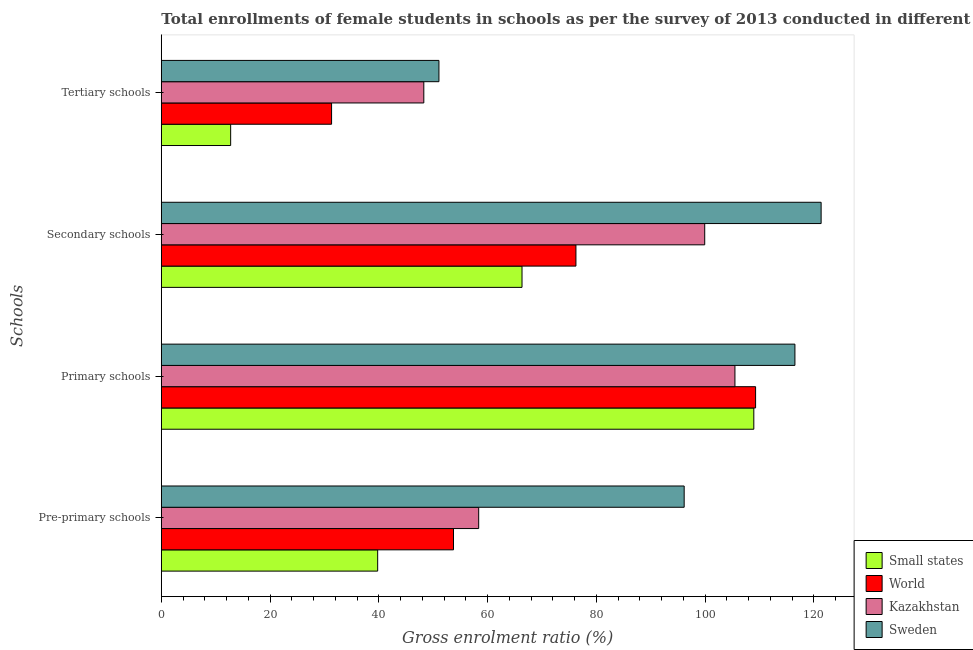Are the number of bars on each tick of the Y-axis equal?
Ensure brevity in your answer.  Yes. How many bars are there on the 3rd tick from the top?
Your answer should be compact. 4. How many bars are there on the 3rd tick from the bottom?
Make the answer very short. 4. What is the label of the 4th group of bars from the top?
Provide a succinct answer. Pre-primary schools. What is the gross enrolment ratio(female) in pre-primary schools in Kazakhstan?
Keep it short and to the point. 58.37. Across all countries, what is the maximum gross enrolment ratio(female) in secondary schools?
Give a very brief answer. 121.36. Across all countries, what is the minimum gross enrolment ratio(female) in primary schools?
Your response must be concise. 105.51. In which country was the gross enrolment ratio(female) in secondary schools minimum?
Provide a short and direct response. Small states. What is the total gross enrolment ratio(female) in primary schools in the graph?
Ensure brevity in your answer.  440.32. What is the difference between the gross enrolment ratio(female) in tertiary schools in Small states and that in Sweden?
Offer a terse response. -38.31. What is the difference between the gross enrolment ratio(female) in primary schools in Kazakhstan and the gross enrolment ratio(female) in secondary schools in Sweden?
Give a very brief answer. -15.85. What is the average gross enrolment ratio(female) in pre-primary schools per country?
Offer a very short reply. 62.02. What is the difference between the gross enrolment ratio(female) in secondary schools and gross enrolment ratio(female) in pre-primary schools in World?
Offer a very short reply. 22.52. In how many countries, is the gross enrolment ratio(female) in primary schools greater than 112 %?
Keep it short and to the point. 1. What is the ratio of the gross enrolment ratio(female) in primary schools in World to that in Sweden?
Your response must be concise. 0.94. Is the gross enrolment ratio(female) in primary schools in Sweden less than that in Kazakhstan?
Offer a terse response. No. What is the difference between the highest and the second highest gross enrolment ratio(female) in pre-primary schools?
Ensure brevity in your answer.  37.79. What is the difference between the highest and the lowest gross enrolment ratio(female) in secondary schools?
Provide a short and direct response. 55.01. In how many countries, is the gross enrolment ratio(female) in pre-primary schools greater than the average gross enrolment ratio(female) in pre-primary schools taken over all countries?
Offer a very short reply. 1. Is it the case that in every country, the sum of the gross enrolment ratio(female) in secondary schools and gross enrolment ratio(female) in pre-primary schools is greater than the sum of gross enrolment ratio(female) in primary schools and gross enrolment ratio(female) in tertiary schools?
Your answer should be very brief. No. What does the 3rd bar from the bottom in Tertiary schools represents?
Make the answer very short. Kazakhstan. How many bars are there?
Ensure brevity in your answer.  16. Are all the bars in the graph horizontal?
Make the answer very short. Yes. Does the graph contain any zero values?
Give a very brief answer. No. How many legend labels are there?
Provide a short and direct response. 4. How are the legend labels stacked?
Keep it short and to the point. Vertical. What is the title of the graph?
Your response must be concise. Total enrollments of female students in schools as per the survey of 2013 conducted in different countries. Does "Japan" appear as one of the legend labels in the graph?
Your answer should be compact. No. What is the label or title of the X-axis?
Keep it short and to the point. Gross enrolment ratio (%). What is the label or title of the Y-axis?
Your answer should be compact. Schools. What is the Gross enrolment ratio (%) in Small states in Pre-primary schools?
Provide a succinct answer. 39.79. What is the Gross enrolment ratio (%) in World in Pre-primary schools?
Make the answer very short. 53.74. What is the Gross enrolment ratio (%) in Kazakhstan in Pre-primary schools?
Your answer should be compact. 58.37. What is the Gross enrolment ratio (%) in Sweden in Pre-primary schools?
Offer a very short reply. 96.17. What is the Gross enrolment ratio (%) in Small states in Primary schools?
Your response must be concise. 108.98. What is the Gross enrolment ratio (%) of World in Primary schools?
Your answer should be very brief. 109.3. What is the Gross enrolment ratio (%) in Kazakhstan in Primary schools?
Provide a succinct answer. 105.51. What is the Gross enrolment ratio (%) of Sweden in Primary schools?
Give a very brief answer. 116.54. What is the Gross enrolment ratio (%) in Small states in Secondary schools?
Offer a very short reply. 66.34. What is the Gross enrolment ratio (%) in World in Secondary schools?
Your answer should be compact. 76.26. What is the Gross enrolment ratio (%) of Kazakhstan in Secondary schools?
Provide a succinct answer. 99.95. What is the Gross enrolment ratio (%) in Sweden in Secondary schools?
Offer a very short reply. 121.36. What is the Gross enrolment ratio (%) in Small states in Tertiary schools?
Offer a terse response. 12.75. What is the Gross enrolment ratio (%) of World in Tertiary schools?
Keep it short and to the point. 31.32. What is the Gross enrolment ratio (%) in Kazakhstan in Tertiary schools?
Ensure brevity in your answer.  48.28. What is the Gross enrolment ratio (%) in Sweden in Tertiary schools?
Ensure brevity in your answer.  51.06. Across all Schools, what is the maximum Gross enrolment ratio (%) in Small states?
Give a very brief answer. 108.98. Across all Schools, what is the maximum Gross enrolment ratio (%) of World?
Ensure brevity in your answer.  109.3. Across all Schools, what is the maximum Gross enrolment ratio (%) of Kazakhstan?
Ensure brevity in your answer.  105.51. Across all Schools, what is the maximum Gross enrolment ratio (%) of Sweden?
Keep it short and to the point. 121.36. Across all Schools, what is the minimum Gross enrolment ratio (%) of Small states?
Offer a terse response. 12.75. Across all Schools, what is the minimum Gross enrolment ratio (%) in World?
Offer a very short reply. 31.32. Across all Schools, what is the minimum Gross enrolment ratio (%) of Kazakhstan?
Offer a terse response. 48.28. Across all Schools, what is the minimum Gross enrolment ratio (%) of Sweden?
Give a very brief answer. 51.06. What is the total Gross enrolment ratio (%) of Small states in the graph?
Offer a terse response. 227.87. What is the total Gross enrolment ratio (%) of World in the graph?
Ensure brevity in your answer.  270.62. What is the total Gross enrolment ratio (%) of Kazakhstan in the graph?
Your answer should be compact. 312.11. What is the total Gross enrolment ratio (%) in Sweden in the graph?
Keep it short and to the point. 385.12. What is the difference between the Gross enrolment ratio (%) of Small states in Pre-primary schools and that in Primary schools?
Provide a short and direct response. -69.18. What is the difference between the Gross enrolment ratio (%) in World in Pre-primary schools and that in Primary schools?
Make the answer very short. -55.56. What is the difference between the Gross enrolment ratio (%) in Kazakhstan in Pre-primary schools and that in Primary schools?
Make the answer very short. -47.13. What is the difference between the Gross enrolment ratio (%) of Sweden in Pre-primary schools and that in Primary schools?
Offer a terse response. -20.37. What is the difference between the Gross enrolment ratio (%) in Small states in Pre-primary schools and that in Secondary schools?
Offer a terse response. -26.55. What is the difference between the Gross enrolment ratio (%) in World in Pre-primary schools and that in Secondary schools?
Make the answer very short. -22.52. What is the difference between the Gross enrolment ratio (%) of Kazakhstan in Pre-primary schools and that in Secondary schools?
Give a very brief answer. -41.57. What is the difference between the Gross enrolment ratio (%) of Sweden in Pre-primary schools and that in Secondary schools?
Ensure brevity in your answer.  -25.19. What is the difference between the Gross enrolment ratio (%) in Small states in Pre-primary schools and that in Tertiary schools?
Your response must be concise. 27.04. What is the difference between the Gross enrolment ratio (%) in World in Pre-primary schools and that in Tertiary schools?
Provide a short and direct response. 22.42. What is the difference between the Gross enrolment ratio (%) in Kazakhstan in Pre-primary schools and that in Tertiary schools?
Your response must be concise. 10.09. What is the difference between the Gross enrolment ratio (%) of Sweden in Pre-primary schools and that in Tertiary schools?
Give a very brief answer. 45.11. What is the difference between the Gross enrolment ratio (%) in Small states in Primary schools and that in Secondary schools?
Offer a terse response. 42.63. What is the difference between the Gross enrolment ratio (%) in World in Primary schools and that in Secondary schools?
Give a very brief answer. 33.04. What is the difference between the Gross enrolment ratio (%) in Kazakhstan in Primary schools and that in Secondary schools?
Offer a terse response. 5.56. What is the difference between the Gross enrolment ratio (%) of Sweden in Primary schools and that in Secondary schools?
Keep it short and to the point. -4.82. What is the difference between the Gross enrolment ratio (%) in Small states in Primary schools and that in Tertiary schools?
Make the answer very short. 96.22. What is the difference between the Gross enrolment ratio (%) of World in Primary schools and that in Tertiary schools?
Offer a very short reply. 77.99. What is the difference between the Gross enrolment ratio (%) of Kazakhstan in Primary schools and that in Tertiary schools?
Your response must be concise. 57.23. What is the difference between the Gross enrolment ratio (%) of Sweden in Primary schools and that in Tertiary schools?
Your answer should be very brief. 65.48. What is the difference between the Gross enrolment ratio (%) in Small states in Secondary schools and that in Tertiary schools?
Your response must be concise. 53.59. What is the difference between the Gross enrolment ratio (%) of World in Secondary schools and that in Tertiary schools?
Make the answer very short. 44.94. What is the difference between the Gross enrolment ratio (%) of Kazakhstan in Secondary schools and that in Tertiary schools?
Provide a short and direct response. 51.67. What is the difference between the Gross enrolment ratio (%) in Sweden in Secondary schools and that in Tertiary schools?
Your answer should be compact. 70.3. What is the difference between the Gross enrolment ratio (%) of Small states in Pre-primary schools and the Gross enrolment ratio (%) of World in Primary schools?
Make the answer very short. -69.51. What is the difference between the Gross enrolment ratio (%) in Small states in Pre-primary schools and the Gross enrolment ratio (%) in Kazakhstan in Primary schools?
Give a very brief answer. -65.71. What is the difference between the Gross enrolment ratio (%) in Small states in Pre-primary schools and the Gross enrolment ratio (%) in Sweden in Primary schools?
Your answer should be compact. -76.74. What is the difference between the Gross enrolment ratio (%) in World in Pre-primary schools and the Gross enrolment ratio (%) in Kazakhstan in Primary schools?
Your answer should be compact. -51.77. What is the difference between the Gross enrolment ratio (%) of World in Pre-primary schools and the Gross enrolment ratio (%) of Sweden in Primary schools?
Provide a short and direct response. -62.8. What is the difference between the Gross enrolment ratio (%) of Kazakhstan in Pre-primary schools and the Gross enrolment ratio (%) of Sweden in Primary schools?
Ensure brevity in your answer.  -58.16. What is the difference between the Gross enrolment ratio (%) in Small states in Pre-primary schools and the Gross enrolment ratio (%) in World in Secondary schools?
Give a very brief answer. -36.47. What is the difference between the Gross enrolment ratio (%) of Small states in Pre-primary schools and the Gross enrolment ratio (%) of Kazakhstan in Secondary schools?
Ensure brevity in your answer.  -60.15. What is the difference between the Gross enrolment ratio (%) of Small states in Pre-primary schools and the Gross enrolment ratio (%) of Sweden in Secondary schools?
Ensure brevity in your answer.  -81.56. What is the difference between the Gross enrolment ratio (%) in World in Pre-primary schools and the Gross enrolment ratio (%) in Kazakhstan in Secondary schools?
Offer a very short reply. -46.21. What is the difference between the Gross enrolment ratio (%) in World in Pre-primary schools and the Gross enrolment ratio (%) in Sweden in Secondary schools?
Provide a succinct answer. -67.62. What is the difference between the Gross enrolment ratio (%) of Kazakhstan in Pre-primary schools and the Gross enrolment ratio (%) of Sweden in Secondary schools?
Offer a terse response. -62.98. What is the difference between the Gross enrolment ratio (%) of Small states in Pre-primary schools and the Gross enrolment ratio (%) of World in Tertiary schools?
Your answer should be compact. 8.48. What is the difference between the Gross enrolment ratio (%) in Small states in Pre-primary schools and the Gross enrolment ratio (%) in Kazakhstan in Tertiary schools?
Keep it short and to the point. -8.48. What is the difference between the Gross enrolment ratio (%) of Small states in Pre-primary schools and the Gross enrolment ratio (%) of Sweden in Tertiary schools?
Ensure brevity in your answer.  -11.27. What is the difference between the Gross enrolment ratio (%) of World in Pre-primary schools and the Gross enrolment ratio (%) of Kazakhstan in Tertiary schools?
Your answer should be very brief. 5.46. What is the difference between the Gross enrolment ratio (%) of World in Pre-primary schools and the Gross enrolment ratio (%) of Sweden in Tertiary schools?
Your answer should be very brief. 2.68. What is the difference between the Gross enrolment ratio (%) in Kazakhstan in Pre-primary schools and the Gross enrolment ratio (%) in Sweden in Tertiary schools?
Keep it short and to the point. 7.31. What is the difference between the Gross enrolment ratio (%) in Small states in Primary schools and the Gross enrolment ratio (%) in World in Secondary schools?
Offer a terse response. 32.72. What is the difference between the Gross enrolment ratio (%) of Small states in Primary schools and the Gross enrolment ratio (%) of Kazakhstan in Secondary schools?
Provide a succinct answer. 9.03. What is the difference between the Gross enrolment ratio (%) of Small states in Primary schools and the Gross enrolment ratio (%) of Sweden in Secondary schools?
Your answer should be compact. -12.38. What is the difference between the Gross enrolment ratio (%) of World in Primary schools and the Gross enrolment ratio (%) of Kazakhstan in Secondary schools?
Offer a terse response. 9.36. What is the difference between the Gross enrolment ratio (%) in World in Primary schools and the Gross enrolment ratio (%) in Sweden in Secondary schools?
Make the answer very short. -12.05. What is the difference between the Gross enrolment ratio (%) in Kazakhstan in Primary schools and the Gross enrolment ratio (%) in Sweden in Secondary schools?
Your response must be concise. -15.85. What is the difference between the Gross enrolment ratio (%) in Small states in Primary schools and the Gross enrolment ratio (%) in World in Tertiary schools?
Your answer should be compact. 77.66. What is the difference between the Gross enrolment ratio (%) in Small states in Primary schools and the Gross enrolment ratio (%) in Kazakhstan in Tertiary schools?
Give a very brief answer. 60.7. What is the difference between the Gross enrolment ratio (%) in Small states in Primary schools and the Gross enrolment ratio (%) in Sweden in Tertiary schools?
Provide a short and direct response. 57.91. What is the difference between the Gross enrolment ratio (%) of World in Primary schools and the Gross enrolment ratio (%) of Kazakhstan in Tertiary schools?
Your response must be concise. 61.02. What is the difference between the Gross enrolment ratio (%) of World in Primary schools and the Gross enrolment ratio (%) of Sweden in Tertiary schools?
Your answer should be compact. 58.24. What is the difference between the Gross enrolment ratio (%) in Kazakhstan in Primary schools and the Gross enrolment ratio (%) in Sweden in Tertiary schools?
Give a very brief answer. 54.44. What is the difference between the Gross enrolment ratio (%) in Small states in Secondary schools and the Gross enrolment ratio (%) in World in Tertiary schools?
Your response must be concise. 35.03. What is the difference between the Gross enrolment ratio (%) in Small states in Secondary schools and the Gross enrolment ratio (%) in Kazakhstan in Tertiary schools?
Provide a short and direct response. 18.06. What is the difference between the Gross enrolment ratio (%) in Small states in Secondary schools and the Gross enrolment ratio (%) in Sweden in Tertiary schools?
Provide a succinct answer. 15.28. What is the difference between the Gross enrolment ratio (%) in World in Secondary schools and the Gross enrolment ratio (%) in Kazakhstan in Tertiary schools?
Your response must be concise. 27.98. What is the difference between the Gross enrolment ratio (%) in World in Secondary schools and the Gross enrolment ratio (%) in Sweden in Tertiary schools?
Keep it short and to the point. 25.2. What is the difference between the Gross enrolment ratio (%) in Kazakhstan in Secondary schools and the Gross enrolment ratio (%) in Sweden in Tertiary schools?
Offer a very short reply. 48.89. What is the average Gross enrolment ratio (%) of Small states per Schools?
Make the answer very short. 56.97. What is the average Gross enrolment ratio (%) in World per Schools?
Provide a succinct answer. 67.65. What is the average Gross enrolment ratio (%) of Kazakhstan per Schools?
Offer a very short reply. 78.03. What is the average Gross enrolment ratio (%) in Sweden per Schools?
Your answer should be compact. 96.28. What is the difference between the Gross enrolment ratio (%) of Small states and Gross enrolment ratio (%) of World in Pre-primary schools?
Provide a succinct answer. -13.94. What is the difference between the Gross enrolment ratio (%) of Small states and Gross enrolment ratio (%) of Kazakhstan in Pre-primary schools?
Offer a very short reply. -18.58. What is the difference between the Gross enrolment ratio (%) in Small states and Gross enrolment ratio (%) in Sweden in Pre-primary schools?
Your response must be concise. -56.37. What is the difference between the Gross enrolment ratio (%) of World and Gross enrolment ratio (%) of Kazakhstan in Pre-primary schools?
Keep it short and to the point. -4.63. What is the difference between the Gross enrolment ratio (%) of World and Gross enrolment ratio (%) of Sweden in Pre-primary schools?
Make the answer very short. -42.43. What is the difference between the Gross enrolment ratio (%) in Kazakhstan and Gross enrolment ratio (%) in Sweden in Pre-primary schools?
Give a very brief answer. -37.79. What is the difference between the Gross enrolment ratio (%) of Small states and Gross enrolment ratio (%) of World in Primary schools?
Your answer should be very brief. -0.33. What is the difference between the Gross enrolment ratio (%) of Small states and Gross enrolment ratio (%) of Kazakhstan in Primary schools?
Your answer should be very brief. 3.47. What is the difference between the Gross enrolment ratio (%) in Small states and Gross enrolment ratio (%) in Sweden in Primary schools?
Provide a succinct answer. -7.56. What is the difference between the Gross enrolment ratio (%) of World and Gross enrolment ratio (%) of Kazakhstan in Primary schools?
Your answer should be compact. 3.8. What is the difference between the Gross enrolment ratio (%) of World and Gross enrolment ratio (%) of Sweden in Primary schools?
Your response must be concise. -7.23. What is the difference between the Gross enrolment ratio (%) of Kazakhstan and Gross enrolment ratio (%) of Sweden in Primary schools?
Your answer should be compact. -11.03. What is the difference between the Gross enrolment ratio (%) of Small states and Gross enrolment ratio (%) of World in Secondary schools?
Offer a terse response. -9.92. What is the difference between the Gross enrolment ratio (%) of Small states and Gross enrolment ratio (%) of Kazakhstan in Secondary schools?
Provide a short and direct response. -33.6. What is the difference between the Gross enrolment ratio (%) of Small states and Gross enrolment ratio (%) of Sweden in Secondary schools?
Keep it short and to the point. -55.01. What is the difference between the Gross enrolment ratio (%) in World and Gross enrolment ratio (%) in Kazakhstan in Secondary schools?
Keep it short and to the point. -23.69. What is the difference between the Gross enrolment ratio (%) in World and Gross enrolment ratio (%) in Sweden in Secondary schools?
Your answer should be compact. -45.1. What is the difference between the Gross enrolment ratio (%) of Kazakhstan and Gross enrolment ratio (%) of Sweden in Secondary schools?
Make the answer very short. -21.41. What is the difference between the Gross enrolment ratio (%) of Small states and Gross enrolment ratio (%) of World in Tertiary schools?
Ensure brevity in your answer.  -18.56. What is the difference between the Gross enrolment ratio (%) of Small states and Gross enrolment ratio (%) of Kazakhstan in Tertiary schools?
Offer a very short reply. -35.53. What is the difference between the Gross enrolment ratio (%) of Small states and Gross enrolment ratio (%) of Sweden in Tertiary schools?
Your answer should be very brief. -38.31. What is the difference between the Gross enrolment ratio (%) of World and Gross enrolment ratio (%) of Kazakhstan in Tertiary schools?
Offer a terse response. -16.96. What is the difference between the Gross enrolment ratio (%) of World and Gross enrolment ratio (%) of Sweden in Tertiary schools?
Your answer should be very brief. -19.75. What is the difference between the Gross enrolment ratio (%) in Kazakhstan and Gross enrolment ratio (%) in Sweden in Tertiary schools?
Make the answer very short. -2.78. What is the ratio of the Gross enrolment ratio (%) in Small states in Pre-primary schools to that in Primary schools?
Provide a short and direct response. 0.37. What is the ratio of the Gross enrolment ratio (%) in World in Pre-primary schools to that in Primary schools?
Give a very brief answer. 0.49. What is the ratio of the Gross enrolment ratio (%) of Kazakhstan in Pre-primary schools to that in Primary schools?
Provide a short and direct response. 0.55. What is the ratio of the Gross enrolment ratio (%) of Sweden in Pre-primary schools to that in Primary schools?
Offer a terse response. 0.83. What is the ratio of the Gross enrolment ratio (%) in Small states in Pre-primary schools to that in Secondary schools?
Your answer should be very brief. 0.6. What is the ratio of the Gross enrolment ratio (%) in World in Pre-primary schools to that in Secondary schools?
Your response must be concise. 0.7. What is the ratio of the Gross enrolment ratio (%) in Kazakhstan in Pre-primary schools to that in Secondary schools?
Give a very brief answer. 0.58. What is the ratio of the Gross enrolment ratio (%) in Sweden in Pre-primary schools to that in Secondary schools?
Offer a terse response. 0.79. What is the ratio of the Gross enrolment ratio (%) of Small states in Pre-primary schools to that in Tertiary schools?
Provide a succinct answer. 3.12. What is the ratio of the Gross enrolment ratio (%) in World in Pre-primary schools to that in Tertiary schools?
Provide a succinct answer. 1.72. What is the ratio of the Gross enrolment ratio (%) in Kazakhstan in Pre-primary schools to that in Tertiary schools?
Provide a succinct answer. 1.21. What is the ratio of the Gross enrolment ratio (%) of Sweden in Pre-primary schools to that in Tertiary schools?
Your answer should be compact. 1.88. What is the ratio of the Gross enrolment ratio (%) in Small states in Primary schools to that in Secondary schools?
Make the answer very short. 1.64. What is the ratio of the Gross enrolment ratio (%) of World in Primary schools to that in Secondary schools?
Keep it short and to the point. 1.43. What is the ratio of the Gross enrolment ratio (%) of Kazakhstan in Primary schools to that in Secondary schools?
Keep it short and to the point. 1.06. What is the ratio of the Gross enrolment ratio (%) of Sweden in Primary schools to that in Secondary schools?
Provide a short and direct response. 0.96. What is the ratio of the Gross enrolment ratio (%) in Small states in Primary schools to that in Tertiary schools?
Keep it short and to the point. 8.54. What is the ratio of the Gross enrolment ratio (%) of World in Primary schools to that in Tertiary schools?
Keep it short and to the point. 3.49. What is the ratio of the Gross enrolment ratio (%) of Kazakhstan in Primary schools to that in Tertiary schools?
Ensure brevity in your answer.  2.19. What is the ratio of the Gross enrolment ratio (%) in Sweden in Primary schools to that in Tertiary schools?
Offer a very short reply. 2.28. What is the ratio of the Gross enrolment ratio (%) of Small states in Secondary schools to that in Tertiary schools?
Make the answer very short. 5.2. What is the ratio of the Gross enrolment ratio (%) in World in Secondary schools to that in Tertiary schools?
Your response must be concise. 2.44. What is the ratio of the Gross enrolment ratio (%) of Kazakhstan in Secondary schools to that in Tertiary schools?
Ensure brevity in your answer.  2.07. What is the ratio of the Gross enrolment ratio (%) in Sweden in Secondary schools to that in Tertiary schools?
Your response must be concise. 2.38. What is the difference between the highest and the second highest Gross enrolment ratio (%) of Small states?
Give a very brief answer. 42.63. What is the difference between the highest and the second highest Gross enrolment ratio (%) in World?
Give a very brief answer. 33.04. What is the difference between the highest and the second highest Gross enrolment ratio (%) in Kazakhstan?
Your answer should be very brief. 5.56. What is the difference between the highest and the second highest Gross enrolment ratio (%) in Sweden?
Offer a terse response. 4.82. What is the difference between the highest and the lowest Gross enrolment ratio (%) of Small states?
Provide a short and direct response. 96.22. What is the difference between the highest and the lowest Gross enrolment ratio (%) of World?
Your response must be concise. 77.99. What is the difference between the highest and the lowest Gross enrolment ratio (%) of Kazakhstan?
Give a very brief answer. 57.23. What is the difference between the highest and the lowest Gross enrolment ratio (%) of Sweden?
Provide a succinct answer. 70.3. 